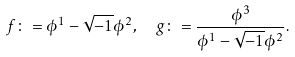Convert formula to latex. <formula><loc_0><loc_0><loc_500><loc_500>f \colon = \phi ^ { 1 } - \sqrt { - 1 } \phi ^ { 2 } , \ \ g \colon = \frac { \phi ^ { 3 } } { \phi ^ { 1 } - \sqrt { - 1 } \phi ^ { 2 } } .</formula> 